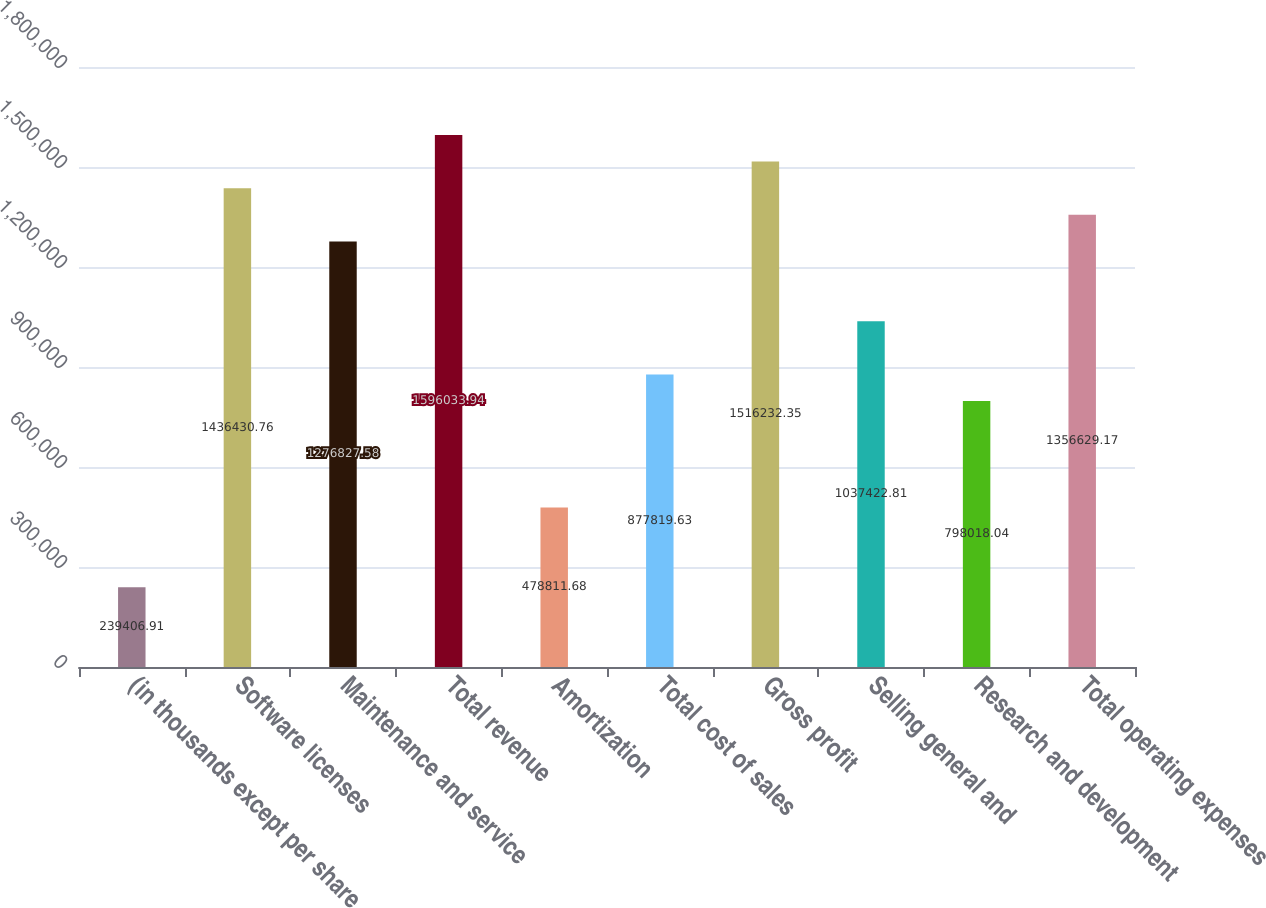Convert chart to OTSL. <chart><loc_0><loc_0><loc_500><loc_500><bar_chart><fcel>(in thousands except per share<fcel>Software licenses<fcel>Maintenance and service<fcel>Total revenue<fcel>Amortization<fcel>Total cost of sales<fcel>Gross profit<fcel>Selling general and<fcel>Research and development<fcel>Total operating expenses<nl><fcel>239407<fcel>1.43643e+06<fcel>1.27683e+06<fcel>1.59603e+06<fcel>478812<fcel>877820<fcel>1.51623e+06<fcel>1.03742e+06<fcel>798018<fcel>1.35663e+06<nl></chart> 